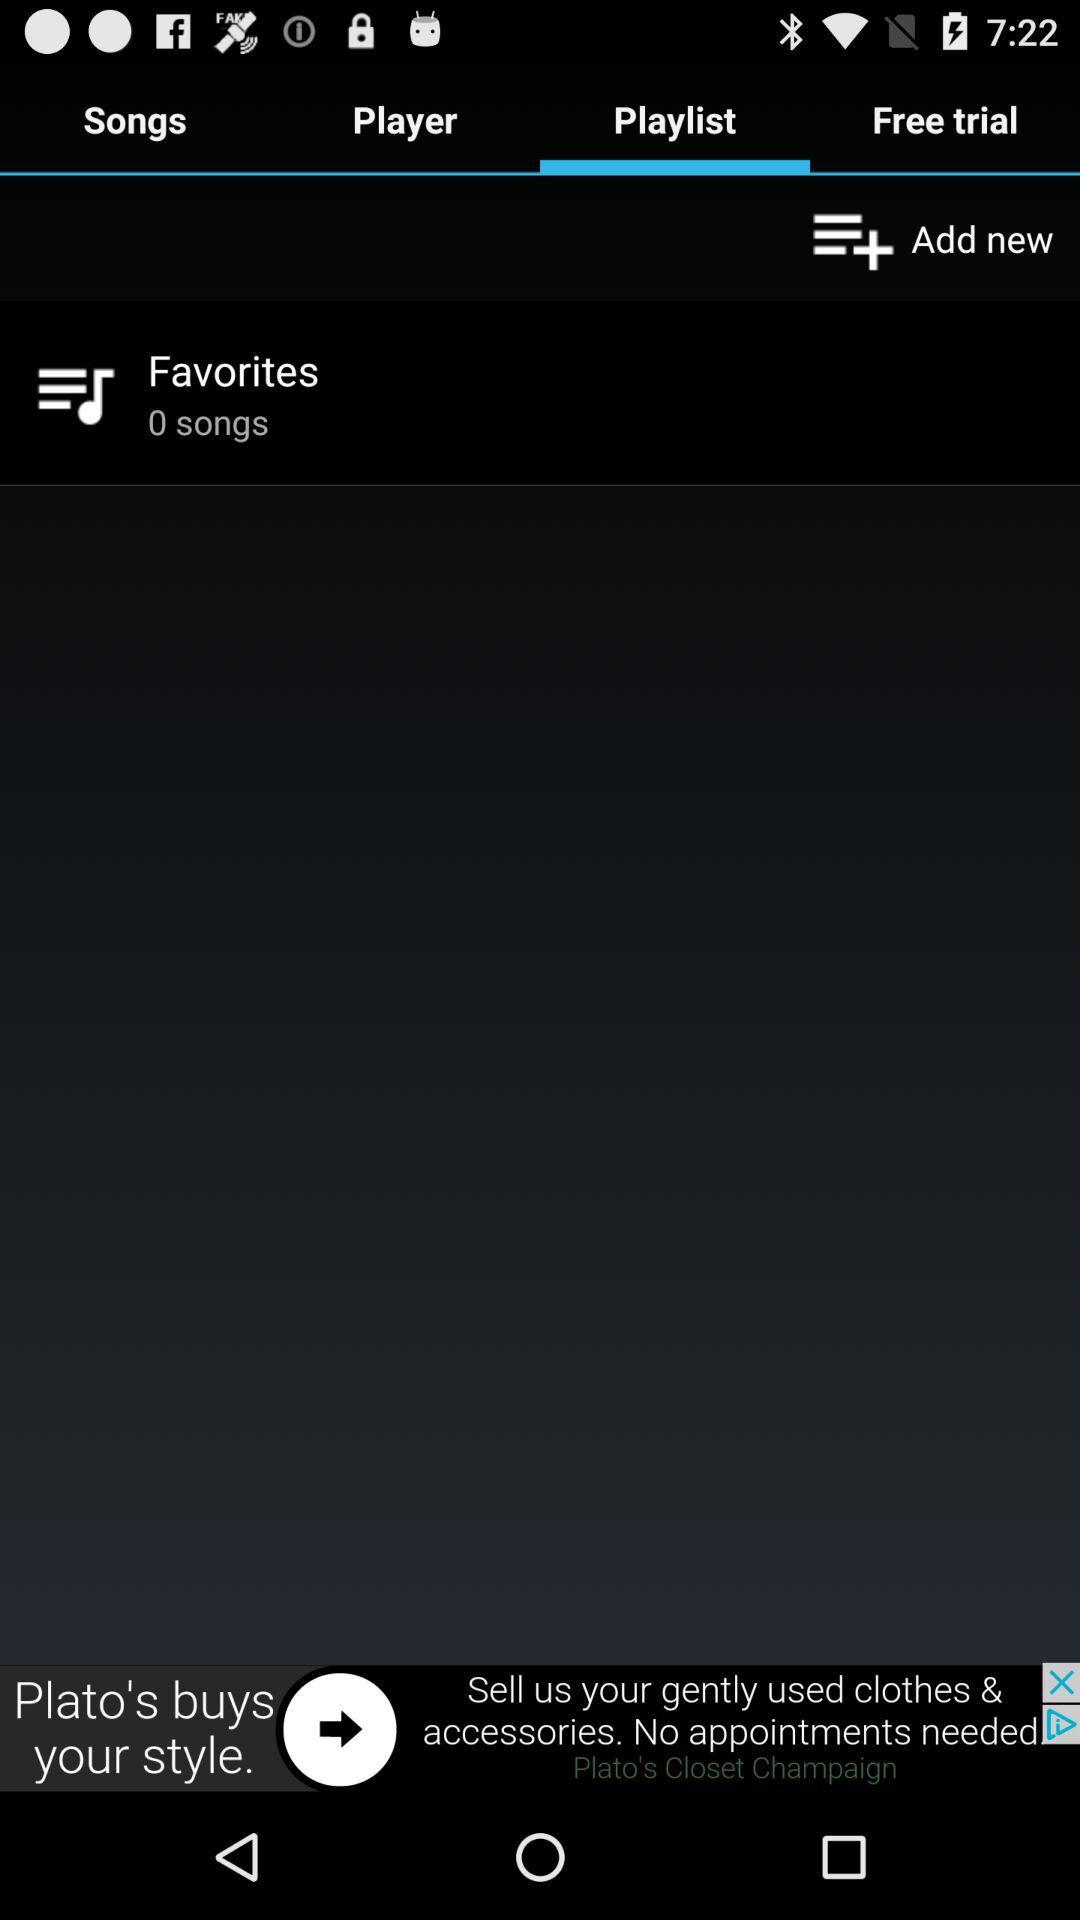What is the number of songs in "Favorites"? The number of songs in "Favorites" is 0. 